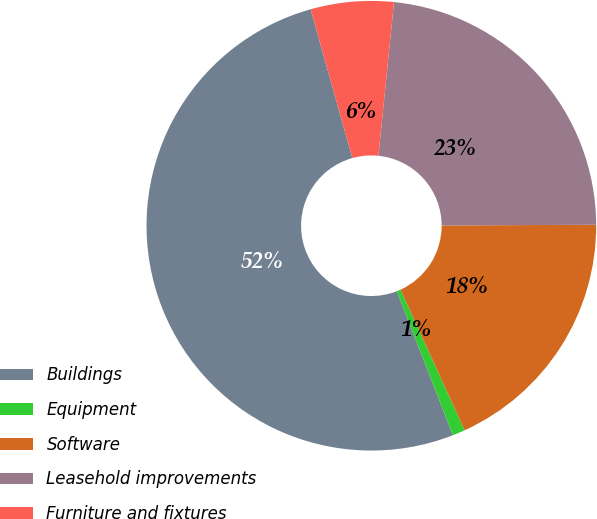Convert chart to OTSL. <chart><loc_0><loc_0><loc_500><loc_500><pie_chart><fcel>Buildings<fcel>Equipment<fcel>Software<fcel>Leasehold improvements<fcel>Furniture and fixtures<nl><fcel>51.56%<fcel>0.9%<fcel>18.26%<fcel>23.33%<fcel>5.96%<nl></chart> 